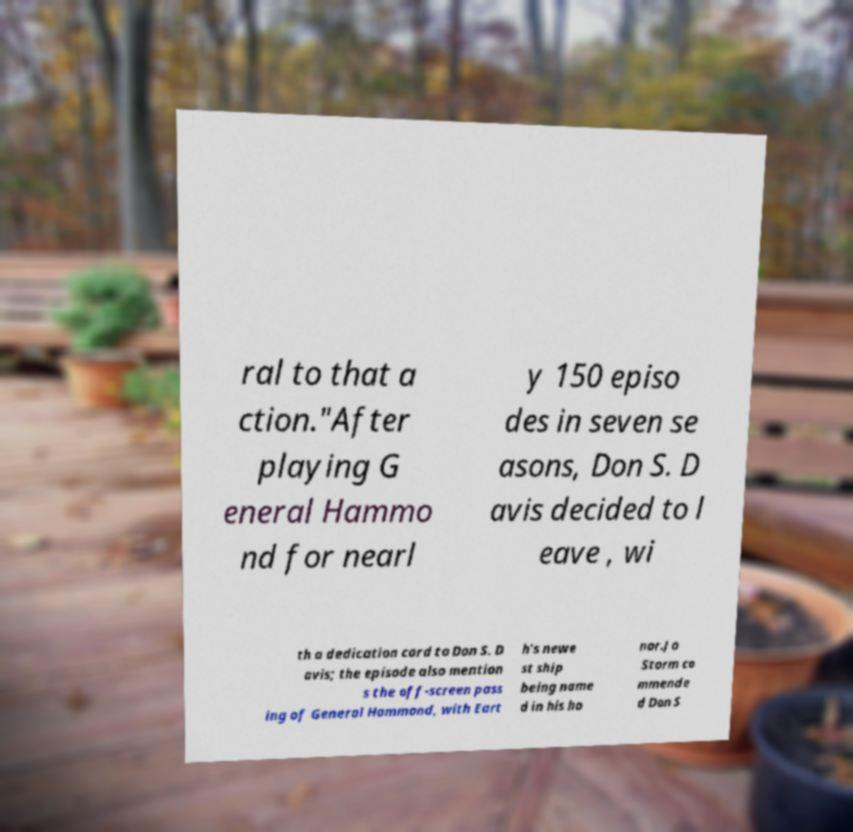Can you read and provide the text displayed in the image?This photo seems to have some interesting text. Can you extract and type it out for me? ral to that a ction."After playing G eneral Hammo nd for nearl y 150 episo des in seven se asons, Don S. D avis decided to l eave , wi th a dedication card to Don S. D avis; the episode also mention s the off-screen pass ing of General Hammond, with Eart h's newe st ship being name d in his ho nor.Jo Storm co mmende d Don S 